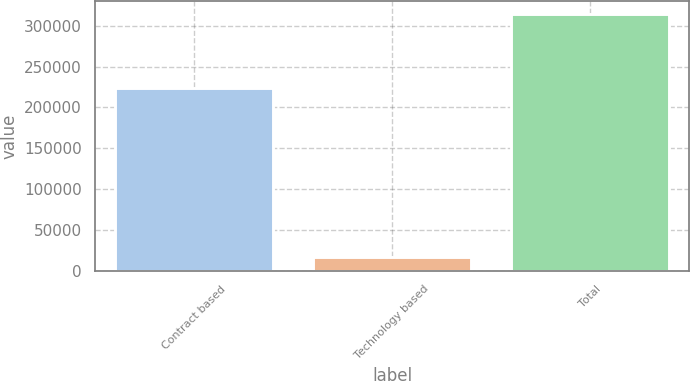Convert chart. <chart><loc_0><loc_0><loc_500><loc_500><bar_chart><fcel>Contract based<fcel>Technology based<fcel>Total<nl><fcel>223873<fcel>17181<fcel>314352<nl></chart> 